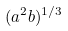Convert formula to latex. <formula><loc_0><loc_0><loc_500><loc_500>( a ^ { 2 } b ) ^ { 1 / 3 }</formula> 